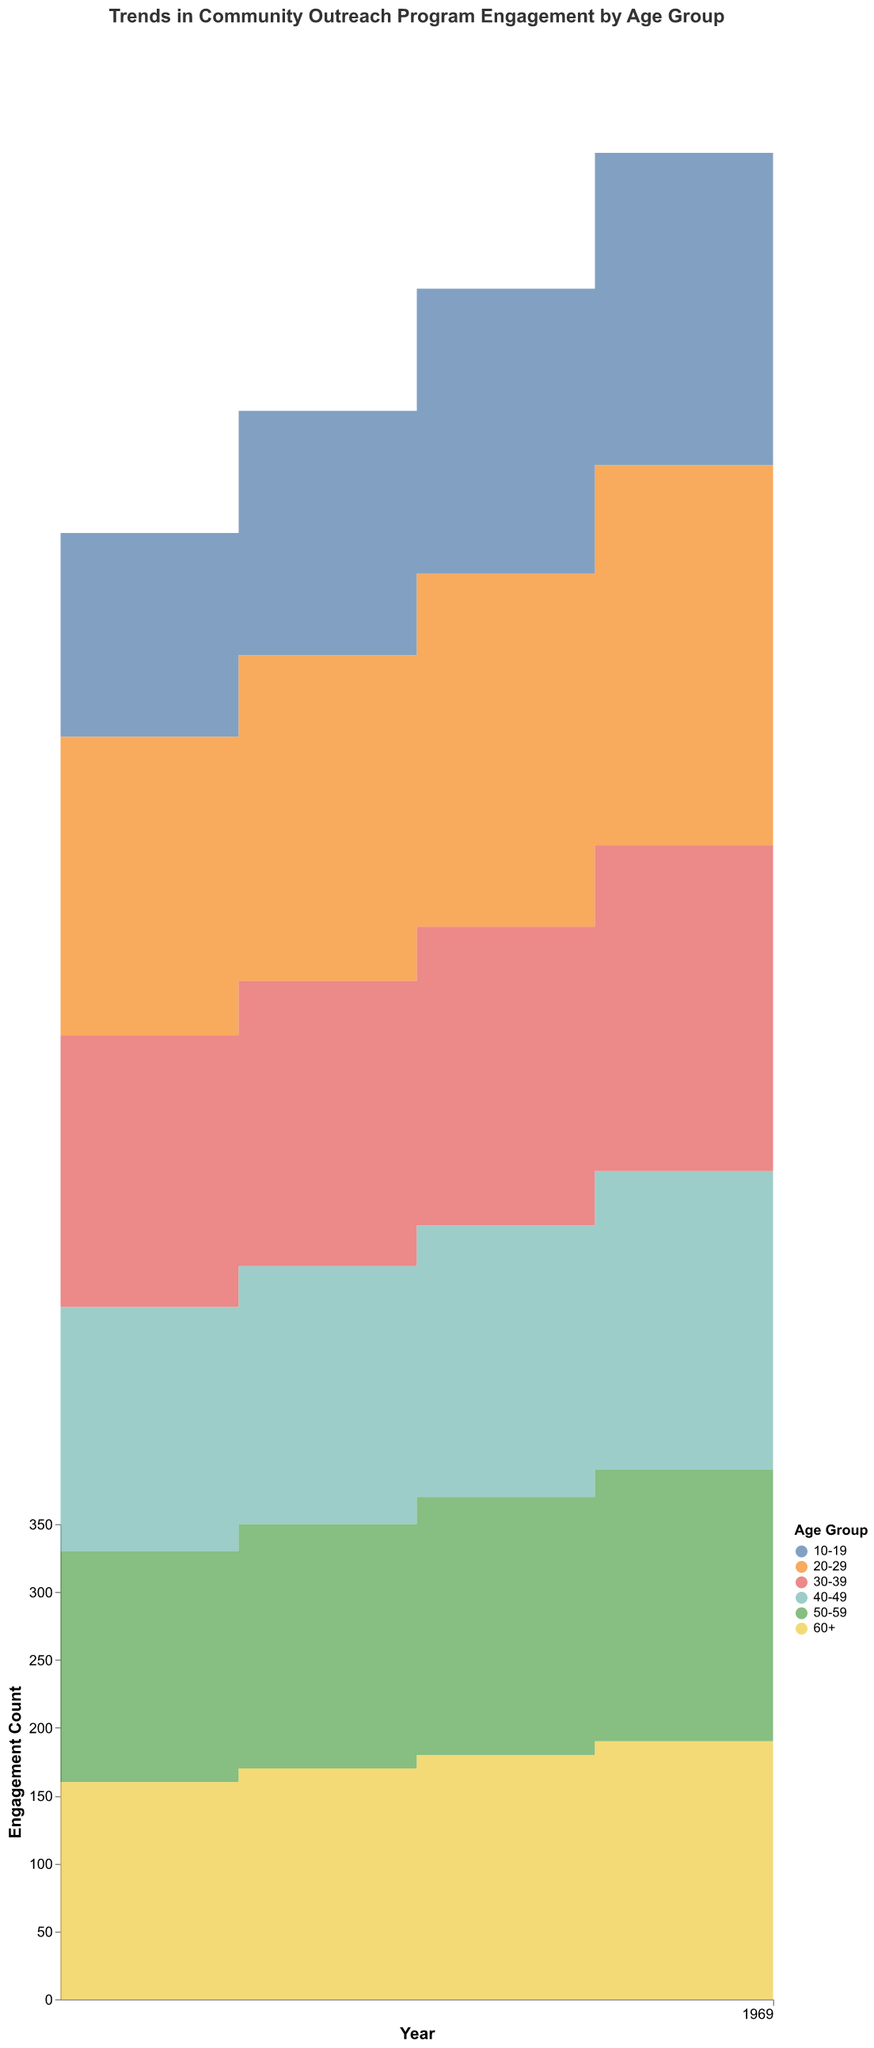What is the title of the chart? The title of the chart is located at the top and summarizes the main theme of the visualization.
Answer: "Trends in Community Outreach Program Engagement by Age Group" How does the engagement count for the 20-29 age group change from 2018 to 2022? By looking at the area for the 20-29 age group over the years 2018 to 2022, we can see the color and height changes. Engagement count increases from 220 in 2018 to 300 in 2022.
Answer: It increases Which age group has the highest engagement count in 2022? To find this, locate the 2022 data points for each age group and compare their heights. The 20-29 age group reaches an engagement count of 300, which is the highest.
Answer: 20-29 Which age group shows the most consistent increase in engagement from 2018 to 2022? Observe the trend lines for each age group from 2018 to 2022. The 60+ age group shows a steady increase in engagement counts from 160 to 200 without a decrease.
Answer: 60+ How many age groups had an engagement count above 200 in 2022? Check the engagement counts for all age groups in 2022 and count how many have values over 200. The 10-19, 20-29, 30-39, and 40-49 groups each had counts above 200.
Answer: Four For which year did the 10-19 age group show the highest increase in engagement? Compare the increments year-over-year for the 10-19 age group. From 2018 to 2019, the increase was 30; from 2019 to 2020, it was 30; from 2020 to 2021, it was 20; from 2021 to 2022, it was 20. The highest increase was at the start between 2018 and 2019.
Answer: 2019 What is the overall trend in total engagement from 2018 to 2022 for all age groups? Summing the engagement counts for all age groups from 2018 to 2022 and examining the trend reveals a general increase: from 1080 in 2018 to 1450 in 2022, indicating an upward trend.
Answer: Increasing Which two adjacent years saw the largest increase in engagement for the 20-29 age group? Look at the changes between each year for the 20-29 age group. The counts are 220 in 2018, 240 in 2019 (20 increase), 260 in 2020 (20 increase), 280 in 2021 (20 increase), and 300 in 2022 (20 increase). All years have equal increases, 20 each time.
Answer: Every year had the same increase What is the engagement count range for the 50-59 age group over the years? Find the highest and lowest engagement counts for the 50-59 age group from the chart. The lowest is 170 in 2018, and the highest is 210 in 2022. The range is 210 - 170 = 40.
Answer: 40 Comparing 2021 and 2022, which age group had the smallest increase in engagement count? Examine each age group's engagement count difference between 2021 and 2022. For 10-19, it's 20 (250-230); for 20-29, it's 20 (300-280); for 30-39, it's 20 (260-240); for 40-49, it's 10 (230-220); for 50-59, it's 10 (210-200); for 60+, it's 10 (200-190). The smallest increase is 10.
Answer: 40-49, 50-59, and 60+ 